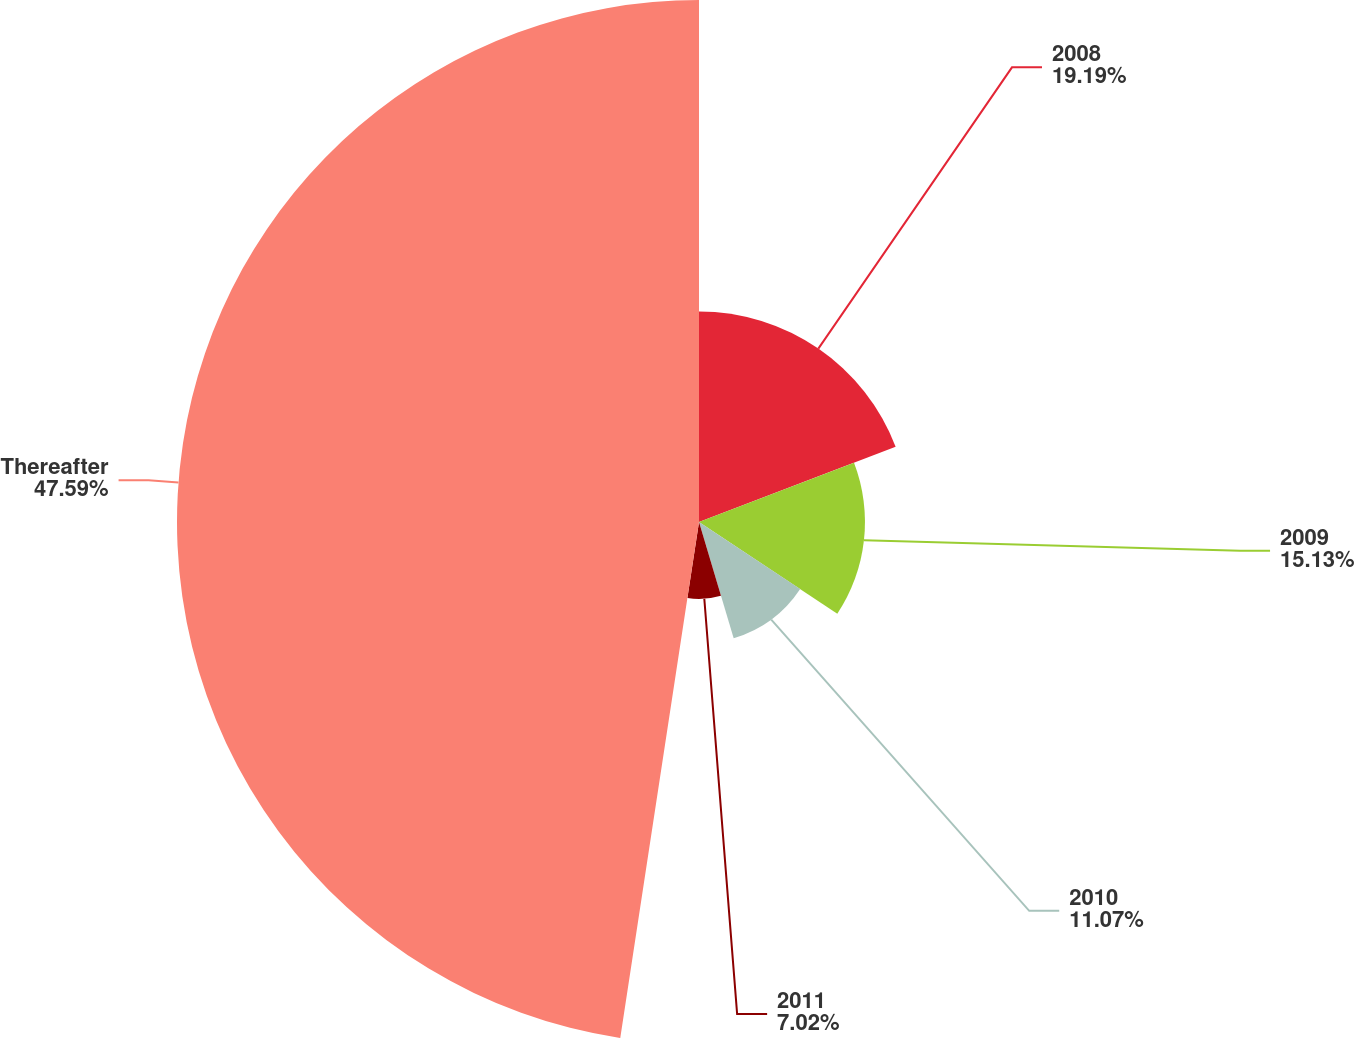<chart> <loc_0><loc_0><loc_500><loc_500><pie_chart><fcel>2008<fcel>2009<fcel>2010<fcel>2011<fcel>Thereafter<nl><fcel>19.19%<fcel>15.13%<fcel>11.07%<fcel>7.02%<fcel>47.59%<nl></chart> 